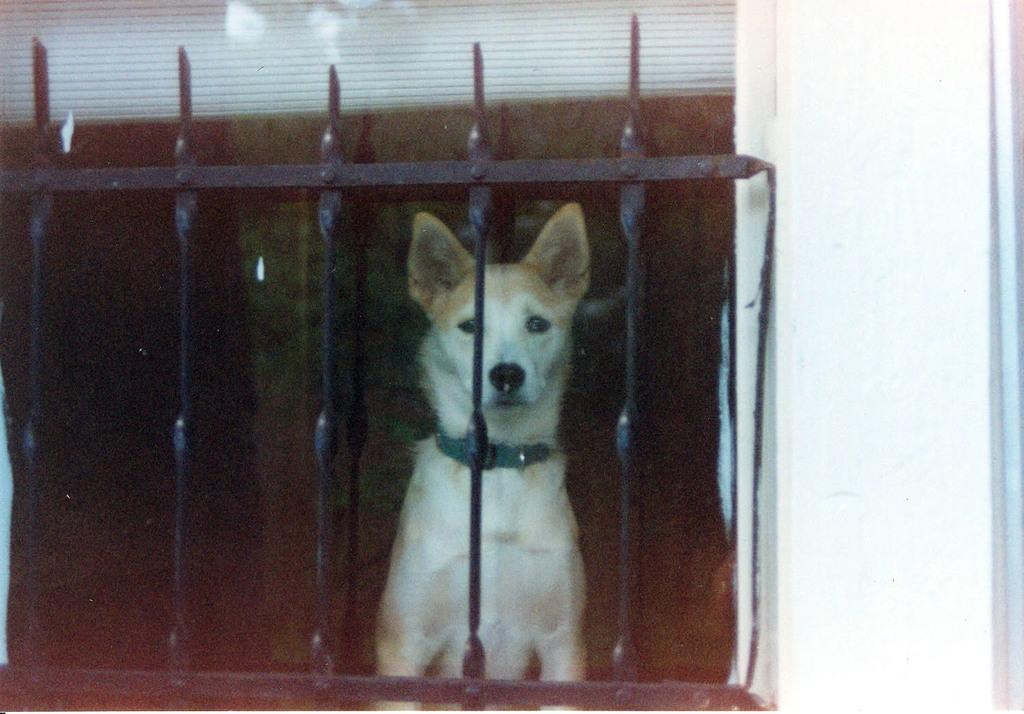What animal can be seen in the image? There is a dog in the image. Where is the dog located in relation to the railing? The dog is sitting behind a black color railing. What colors can be seen on the dog? The dog is white and brown in color. What is the color of the wall on the right side of the image? There is a white color wall on the right side of the image. How does the dog compare to the pot in the image? There is no pot present in the image, so it is not possible to make a comparison. 